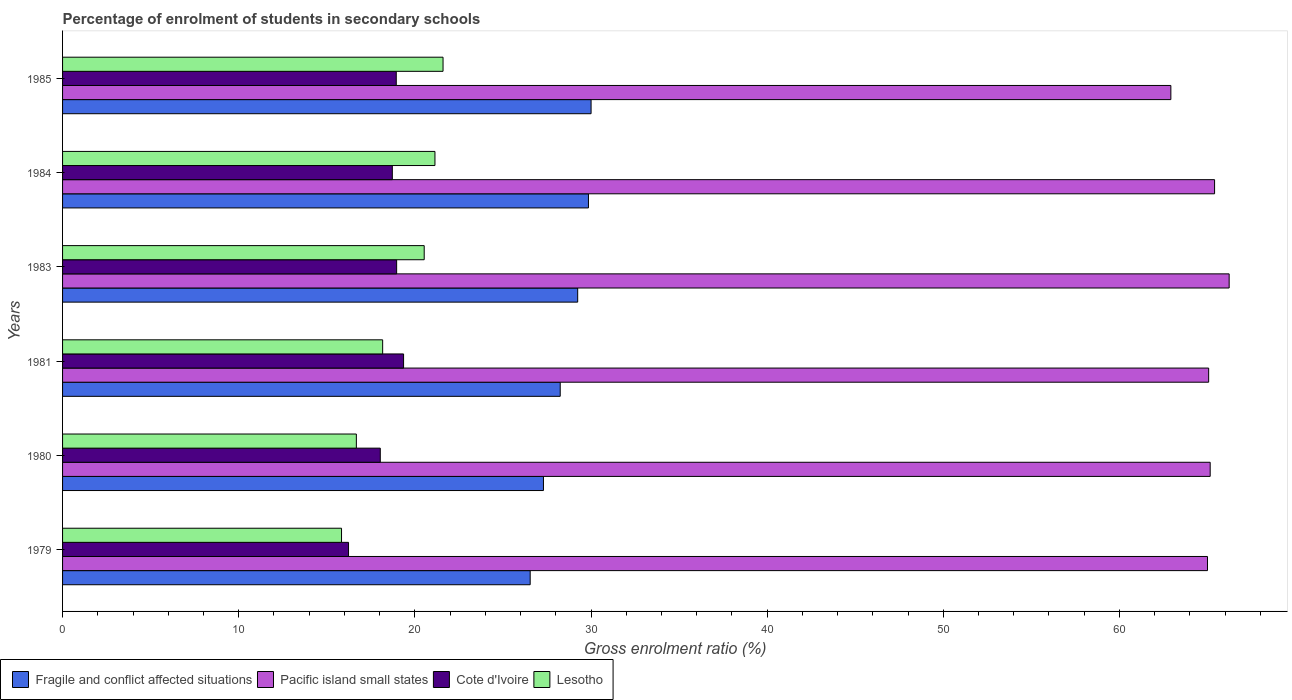Are the number of bars on each tick of the Y-axis equal?
Your answer should be very brief. Yes. How many bars are there on the 5th tick from the top?
Your answer should be very brief. 4. How many bars are there on the 2nd tick from the bottom?
Offer a very short reply. 4. In how many cases, is the number of bars for a given year not equal to the number of legend labels?
Your answer should be compact. 0. What is the percentage of students enrolled in secondary schools in Fragile and conflict affected situations in 1983?
Ensure brevity in your answer.  29.24. Across all years, what is the maximum percentage of students enrolled in secondary schools in Fragile and conflict affected situations?
Give a very brief answer. 30.01. Across all years, what is the minimum percentage of students enrolled in secondary schools in Fragile and conflict affected situations?
Provide a succinct answer. 26.55. In which year was the percentage of students enrolled in secondary schools in Lesotho maximum?
Keep it short and to the point. 1985. In which year was the percentage of students enrolled in secondary schools in Lesotho minimum?
Your answer should be very brief. 1979. What is the total percentage of students enrolled in secondary schools in Fragile and conflict affected situations in the graph?
Provide a short and direct response. 171.21. What is the difference between the percentage of students enrolled in secondary schools in Fragile and conflict affected situations in 1980 and that in 1981?
Your answer should be compact. -0.95. What is the difference between the percentage of students enrolled in secondary schools in Pacific island small states in 1983 and the percentage of students enrolled in secondary schools in Cote d'Ivoire in 1984?
Give a very brief answer. 47.51. What is the average percentage of students enrolled in secondary schools in Pacific island small states per year?
Your answer should be compact. 64.96. In the year 1984, what is the difference between the percentage of students enrolled in secondary schools in Lesotho and percentage of students enrolled in secondary schools in Cote d'Ivoire?
Provide a short and direct response. 2.42. In how many years, is the percentage of students enrolled in secondary schools in Cote d'Ivoire greater than 48 %?
Your response must be concise. 0. What is the ratio of the percentage of students enrolled in secondary schools in Pacific island small states in 1980 to that in 1981?
Keep it short and to the point. 1. Is the percentage of students enrolled in secondary schools in Lesotho in 1983 less than that in 1984?
Your answer should be compact. Yes. Is the difference between the percentage of students enrolled in secondary schools in Lesotho in 1979 and 1984 greater than the difference between the percentage of students enrolled in secondary schools in Cote d'Ivoire in 1979 and 1984?
Provide a short and direct response. No. What is the difference between the highest and the second highest percentage of students enrolled in secondary schools in Lesotho?
Ensure brevity in your answer.  0.46. What is the difference between the highest and the lowest percentage of students enrolled in secondary schools in Cote d'Ivoire?
Keep it short and to the point. 3.13. In how many years, is the percentage of students enrolled in secondary schools in Lesotho greater than the average percentage of students enrolled in secondary schools in Lesotho taken over all years?
Keep it short and to the point. 3. Is the sum of the percentage of students enrolled in secondary schools in Fragile and conflict affected situations in 1979 and 1983 greater than the maximum percentage of students enrolled in secondary schools in Lesotho across all years?
Ensure brevity in your answer.  Yes. Is it the case that in every year, the sum of the percentage of students enrolled in secondary schools in Fragile and conflict affected situations and percentage of students enrolled in secondary schools in Lesotho is greater than the sum of percentage of students enrolled in secondary schools in Pacific island small states and percentage of students enrolled in secondary schools in Cote d'Ivoire?
Provide a succinct answer. Yes. What does the 4th bar from the top in 1979 represents?
Ensure brevity in your answer.  Fragile and conflict affected situations. What does the 4th bar from the bottom in 1983 represents?
Give a very brief answer. Lesotho. How many bars are there?
Your response must be concise. 24. How many years are there in the graph?
Offer a terse response. 6. Are the values on the major ticks of X-axis written in scientific E-notation?
Give a very brief answer. No. Does the graph contain any zero values?
Your answer should be compact. No. Does the graph contain grids?
Offer a very short reply. No. How many legend labels are there?
Offer a very short reply. 4. How are the legend labels stacked?
Provide a succinct answer. Horizontal. What is the title of the graph?
Make the answer very short. Percentage of enrolment of students in secondary schools. What is the label or title of the X-axis?
Make the answer very short. Gross enrolment ratio (%). What is the Gross enrolment ratio (%) in Fragile and conflict affected situations in 1979?
Offer a terse response. 26.55. What is the Gross enrolment ratio (%) of Pacific island small states in 1979?
Your response must be concise. 65. What is the Gross enrolment ratio (%) in Cote d'Ivoire in 1979?
Give a very brief answer. 16.23. What is the Gross enrolment ratio (%) in Lesotho in 1979?
Provide a succinct answer. 15.84. What is the Gross enrolment ratio (%) of Fragile and conflict affected situations in 1980?
Your answer should be compact. 27.3. What is the Gross enrolment ratio (%) of Pacific island small states in 1980?
Offer a terse response. 65.15. What is the Gross enrolment ratio (%) in Cote d'Ivoire in 1980?
Offer a very short reply. 18.04. What is the Gross enrolment ratio (%) in Lesotho in 1980?
Offer a terse response. 16.68. What is the Gross enrolment ratio (%) of Fragile and conflict affected situations in 1981?
Offer a terse response. 28.25. What is the Gross enrolment ratio (%) of Pacific island small states in 1981?
Provide a succinct answer. 65.07. What is the Gross enrolment ratio (%) of Cote d'Ivoire in 1981?
Give a very brief answer. 19.36. What is the Gross enrolment ratio (%) of Lesotho in 1981?
Offer a terse response. 18.17. What is the Gross enrolment ratio (%) in Fragile and conflict affected situations in 1983?
Offer a terse response. 29.24. What is the Gross enrolment ratio (%) of Pacific island small states in 1983?
Your answer should be very brief. 66.23. What is the Gross enrolment ratio (%) of Cote d'Ivoire in 1983?
Your response must be concise. 18.97. What is the Gross enrolment ratio (%) of Lesotho in 1983?
Your answer should be compact. 20.53. What is the Gross enrolment ratio (%) in Fragile and conflict affected situations in 1984?
Your response must be concise. 29.86. What is the Gross enrolment ratio (%) in Pacific island small states in 1984?
Ensure brevity in your answer.  65.4. What is the Gross enrolment ratio (%) of Cote d'Ivoire in 1984?
Offer a terse response. 18.72. What is the Gross enrolment ratio (%) in Lesotho in 1984?
Your answer should be compact. 21.14. What is the Gross enrolment ratio (%) in Fragile and conflict affected situations in 1985?
Your answer should be compact. 30.01. What is the Gross enrolment ratio (%) in Pacific island small states in 1985?
Ensure brevity in your answer.  62.92. What is the Gross enrolment ratio (%) in Cote d'Ivoire in 1985?
Provide a succinct answer. 18.94. What is the Gross enrolment ratio (%) of Lesotho in 1985?
Offer a very short reply. 21.6. Across all years, what is the maximum Gross enrolment ratio (%) of Fragile and conflict affected situations?
Ensure brevity in your answer.  30.01. Across all years, what is the maximum Gross enrolment ratio (%) of Pacific island small states?
Ensure brevity in your answer.  66.23. Across all years, what is the maximum Gross enrolment ratio (%) in Cote d'Ivoire?
Offer a terse response. 19.36. Across all years, what is the maximum Gross enrolment ratio (%) in Lesotho?
Keep it short and to the point. 21.6. Across all years, what is the minimum Gross enrolment ratio (%) in Fragile and conflict affected situations?
Give a very brief answer. 26.55. Across all years, what is the minimum Gross enrolment ratio (%) in Pacific island small states?
Give a very brief answer. 62.92. Across all years, what is the minimum Gross enrolment ratio (%) in Cote d'Ivoire?
Ensure brevity in your answer.  16.23. Across all years, what is the minimum Gross enrolment ratio (%) in Lesotho?
Your answer should be compact. 15.84. What is the total Gross enrolment ratio (%) in Fragile and conflict affected situations in the graph?
Provide a short and direct response. 171.21. What is the total Gross enrolment ratio (%) of Pacific island small states in the graph?
Make the answer very short. 389.77. What is the total Gross enrolment ratio (%) of Cote d'Ivoire in the graph?
Offer a terse response. 110.26. What is the total Gross enrolment ratio (%) of Lesotho in the graph?
Your answer should be very brief. 113.96. What is the difference between the Gross enrolment ratio (%) in Fragile and conflict affected situations in 1979 and that in 1980?
Offer a very short reply. -0.75. What is the difference between the Gross enrolment ratio (%) in Pacific island small states in 1979 and that in 1980?
Offer a very short reply. -0.15. What is the difference between the Gross enrolment ratio (%) of Cote d'Ivoire in 1979 and that in 1980?
Provide a succinct answer. -1.8. What is the difference between the Gross enrolment ratio (%) of Lesotho in 1979 and that in 1980?
Provide a short and direct response. -0.84. What is the difference between the Gross enrolment ratio (%) in Fragile and conflict affected situations in 1979 and that in 1981?
Keep it short and to the point. -1.7. What is the difference between the Gross enrolment ratio (%) of Pacific island small states in 1979 and that in 1981?
Give a very brief answer. -0.07. What is the difference between the Gross enrolment ratio (%) in Cote d'Ivoire in 1979 and that in 1981?
Give a very brief answer. -3.13. What is the difference between the Gross enrolment ratio (%) in Lesotho in 1979 and that in 1981?
Provide a succinct answer. -2.33. What is the difference between the Gross enrolment ratio (%) in Fragile and conflict affected situations in 1979 and that in 1983?
Offer a terse response. -2.7. What is the difference between the Gross enrolment ratio (%) of Pacific island small states in 1979 and that in 1983?
Your answer should be compact. -1.23. What is the difference between the Gross enrolment ratio (%) in Cote d'Ivoire in 1979 and that in 1983?
Provide a succinct answer. -2.73. What is the difference between the Gross enrolment ratio (%) in Lesotho in 1979 and that in 1983?
Keep it short and to the point. -4.69. What is the difference between the Gross enrolment ratio (%) of Fragile and conflict affected situations in 1979 and that in 1984?
Offer a very short reply. -3.31. What is the difference between the Gross enrolment ratio (%) in Pacific island small states in 1979 and that in 1984?
Offer a terse response. -0.4. What is the difference between the Gross enrolment ratio (%) of Cote d'Ivoire in 1979 and that in 1984?
Give a very brief answer. -2.49. What is the difference between the Gross enrolment ratio (%) of Lesotho in 1979 and that in 1984?
Offer a terse response. -5.3. What is the difference between the Gross enrolment ratio (%) of Fragile and conflict affected situations in 1979 and that in 1985?
Your response must be concise. -3.46. What is the difference between the Gross enrolment ratio (%) of Pacific island small states in 1979 and that in 1985?
Make the answer very short. 2.08. What is the difference between the Gross enrolment ratio (%) in Cote d'Ivoire in 1979 and that in 1985?
Your answer should be very brief. -2.71. What is the difference between the Gross enrolment ratio (%) in Lesotho in 1979 and that in 1985?
Your answer should be compact. -5.76. What is the difference between the Gross enrolment ratio (%) of Fragile and conflict affected situations in 1980 and that in 1981?
Your answer should be very brief. -0.95. What is the difference between the Gross enrolment ratio (%) in Pacific island small states in 1980 and that in 1981?
Your answer should be compact. 0.09. What is the difference between the Gross enrolment ratio (%) in Cote d'Ivoire in 1980 and that in 1981?
Make the answer very short. -1.32. What is the difference between the Gross enrolment ratio (%) in Lesotho in 1980 and that in 1981?
Provide a short and direct response. -1.49. What is the difference between the Gross enrolment ratio (%) in Fragile and conflict affected situations in 1980 and that in 1983?
Offer a very short reply. -1.94. What is the difference between the Gross enrolment ratio (%) in Pacific island small states in 1980 and that in 1983?
Keep it short and to the point. -1.08. What is the difference between the Gross enrolment ratio (%) of Cote d'Ivoire in 1980 and that in 1983?
Provide a succinct answer. -0.93. What is the difference between the Gross enrolment ratio (%) in Lesotho in 1980 and that in 1983?
Your answer should be compact. -3.85. What is the difference between the Gross enrolment ratio (%) of Fragile and conflict affected situations in 1980 and that in 1984?
Provide a succinct answer. -2.56. What is the difference between the Gross enrolment ratio (%) of Pacific island small states in 1980 and that in 1984?
Offer a very short reply. -0.25. What is the difference between the Gross enrolment ratio (%) in Cote d'Ivoire in 1980 and that in 1984?
Make the answer very short. -0.68. What is the difference between the Gross enrolment ratio (%) of Lesotho in 1980 and that in 1984?
Your answer should be compact. -4.46. What is the difference between the Gross enrolment ratio (%) of Fragile and conflict affected situations in 1980 and that in 1985?
Your answer should be very brief. -2.7. What is the difference between the Gross enrolment ratio (%) in Pacific island small states in 1980 and that in 1985?
Your answer should be compact. 2.23. What is the difference between the Gross enrolment ratio (%) in Cote d'Ivoire in 1980 and that in 1985?
Make the answer very short. -0.91. What is the difference between the Gross enrolment ratio (%) of Lesotho in 1980 and that in 1985?
Your answer should be compact. -4.92. What is the difference between the Gross enrolment ratio (%) in Fragile and conflict affected situations in 1981 and that in 1983?
Your answer should be very brief. -0.99. What is the difference between the Gross enrolment ratio (%) of Pacific island small states in 1981 and that in 1983?
Your answer should be very brief. -1.16. What is the difference between the Gross enrolment ratio (%) of Cote d'Ivoire in 1981 and that in 1983?
Offer a terse response. 0.39. What is the difference between the Gross enrolment ratio (%) of Lesotho in 1981 and that in 1983?
Give a very brief answer. -2.36. What is the difference between the Gross enrolment ratio (%) in Fragile and conflict affected situations in 1981 and that in 1984?
Your answer should be compact. -1.6. What is the difference between the Gross enrolment ratio (%) in Pacific island small states in 1981 and that in 1984?
Your answer should be very brief. -0.34. What is the difference between the Gross enrolment ratio (%) of Cote d'Ivoire in 1981 and that in 1984?
Offer a terse response. 0.64. What is the difference between the Gross enrolment ratio (%) in Lesotho in 1981 and that in 1984?
Your response must be concise. -2.97. What is the difference between the Gross enrolment ratio (%) of Fragile and conflict affected situations in 1981 and that in 1985?
Offer a terse response. -1.75. What is the difference between the Gross enrolment ratio (%) in Pacific island small states in 1981 and that in 1985?
Offer a terse response. 2.15. What is the difference between the Gross enrolment ratio (%) of Cote d'Ivoire in 1981 and that in 1985?
Give a very brief answer. 0.41. What is the difference between the Gross enrolment ratio (%) in Lesotho in 1981 and that in 1985?
Keep it short and to the point. -3.43. What is the difference between the Gross enrolment ratio (%) in Fragile and conflict affected situations in 1983 and that in 1984?
Your answer should be compact. -0.61. What is the difference between the Gross enrolment ratio (%) of Pacific island small states in 1983 and that in 1984?
Make the answer very short. 0.83. What is the difference between the Gross enrolment ratio (%) of Cote d'Ivoire in 1983 and that in 1984?
Give a very brief answer. 0.25. What is the difference between the Gross enrolment ratio (%) of Lesotho in 1983 and that in 1984?
Offer a very short reply. -0.61. What is the difference between the Gross enrolment ratio (%) of Fragile and conflict affected situations in 1983 and that in 1985?
Your answer should be compact. -0.76. What is the difference between the Gross enrolment ratio (%) in Pacific island small states in 1983 and that in 1985?
Provide a short and direct response. 3.31. What is the difference between the Gross enrolment ratio (%) in Cote d'Ivoire in 1983 and that in 1985?
Provide a short and direct response. 0.02. What is the difference between the Gross enrolment ratio (%) of Lesotho in 1983 and that in 1985?
Give a very brief answer. -1.07. What is the difference between the Gross enrolment ratio (%) of Fragile and conflict affected situations in 1984 and that in 1985?
Provide a short and direct response. -0.15. What is the difference between the Gross enrolment ratio (%) in Pacific island small states in 1984 and that in 1985?
Make the answer very short. 2.48. What is the difference between the Gross enrolment ratio (%) of Cote d'Ivoire in 1984 and that in 1985?
Offer a terse response. -0.22. What is the difference between the Gross enrolment ratio (%) of Lesotho in 1984 and that in 1985?
Ensure brevity in your answer.  -0.46. What is the difference between the Gross enrolment ratio (%) in Fragile and conflict affected situations in 1979 and the Gross enrolment ratio (%) in Pacific island small states in 1980?
Provide a succinct answer. -38.61. What is the difference between the Gross enrolment ratio (%) of Fragile and conflict affected situations in 1979 and the Gross enrolment ratio (%) of Cote d'Ivoire in 1980?
Offer a very short reply. 8.51. What is the difference between the Gross enrolment ratio (%) in Fragile and conflict affected situations in 1979 and the Gross enrolment ratio (%) in Lesotho in 1980?
Provide a short and direct response. 9.87. What is the difference between the Gross enrolment ratio (%) of Pacific island small states in 1979 and the Gross enrolment ratio (%) of Cote d'Ivoire in 1980?
Your answer should be compact. 46.96. What is the difference between the Gross enrolment ratio (%) of Pacific island small states in 1979 and the Gross enrolment ratio (%) of Lesotho in 1980?
Provide a short and direct response. 48.32. What is the difference between the Gross enrolment ratio (%) of Cote d'Ivoire in 1979 and the Gross enrolment ratio (%) of Lesotho in 1980?
Your response must be concise. -0.45. What is the difference between the Gross enrolment ratio (%) in Fragile and conflict affected situations in 1979 and the Gross enrolment ratio (%) in Pacific island small states in 1981?
Offer a very short reply. -38.52. What is the difference between the Gross enrolment ratio (%) in Fragile and conflict affected situations in 1979 and the Gross enrolment ratio (%) in Cote d'Ivoire in 1981?
Keep it short and to the point. 7.19. What is the difference between the Gross enrolment ratio (%) of Fragile and conflict affected situations in 1979 and the Gross enrolment ratio (%) of Lesotho in 1981?
Provide a short and direct response. 8.38. What is the difference between the Gross enrolment ratio (%) in Pacific island small states in 1979 and the Gross enrolment ratio (%) in Cote d'Ivoire in 1981?
Offer a very short reply. 45.64. What is the difference between the Gross enrolment ratio (%) of Pacific island small states in 1979 and the Gross enrolment ratio (%) of Lesotho in 1981?
Ensure brevity in your answer.  46.83. What is the difference between the Gross enrolment ratio (%) in Cote d'Ivoire in 1979 and the Gross enrolment ratio (%) in Lesotho in 1981?
Make the answer very short. -1.94. What is the difference between the Gross enrolment ratio (%) of Fragile and conflict affected situations in 1979 and the Gross enrolment ratio (%) of Pacific island small states in 1983?
Offer a very short reply. -39.68. What is the difference between the Gross enrolment ratio (%) of Fragile and conflict affected situations in 1979 and the Gross enrolment ratio (%) of Cote d'Ivoire in 1983?
Keep it short and to the point. 7.58. What is the difference between the Gross enrolment ratio (%) in Fragile and conflict affected situations in 1979 and the Gross enrolment ratio (%) in Lesotho in 1983?
Your response must be concise. 6.02. What is the difference between the Gross enrolment ratio (%) of Pacific island small states in 1979 and the Gross enrolment ratio (%) of Cote d'Ivoire in 1983?
Your answer should be very brief. 46.03. What is the difference between the Gross enrolment ratio (%) of Pacific island small states in 1979 and the Gross enrolment ratio (%) of Lesotho in 1983?
Keep it short and to the point. 44.47. What is the difference between the Gross enrolment ratio (%) of Cote d'Ivoire in 1979 and the Gross enrolment ratio (%) of Lesotho in 1983?
Give a very brief answer. -4.3. What is the difference between the Gross enrolment ratio (%) of Fragile and conflict affected situations in 1979 and the Gross enrolment ratio (%) of Pacific island small states in 1984?
Ensure brevity in your answer.  -38.85. What is the difference between the Gross enrolment ratio (%) of Fragile and conflict affected situations in 1979 and the Gross enrolment ratio (%) of Cote d'Ivoire in 1984?
Your response must be concise. 7.83. What is the difference between the Gross enrolment ratio (%) in Fragile and conflict affected situations in 1979 and the Gross enrolment ratio (%) in Lesotho in 1984?
Keep it short and to the point. 5.41. What is the difference between the Gross enrolment ratio (%) in Pacific island small states in 1979 and the Gross enrolment ratio (%) in Cote d'Ivoire in 1984?
Make the answer very short. 46.28. What is the difference between the Gross enrolment ratio (%) of Pacific island small states in 1979 and the Gross enrolment ratio (%) of Lesotho in 1984?
Offer a terse response. 43.86. What is the difference between the Gross enrolment ratio (%) in Cote d'Ivoire in 1979 and the Gross enrolment ratio (%) in Lesotho in 1984?
Offer a very short reply. -4.91. What is the difference between the Gross enrolment ratio (%) of Fragile and conflict affected situations in 1979 and the Gross enrolment ratio (%) of Pacific island small states in 1985?
Keep it short and to the point. -36.37. What is the difference between the Gross enrolment ratio (%) of Fragile and conflict affected situations in 1979 and the Gross enrolment ratio (%) of Cote d'Ivoire in 1985?
Your answer should be compact. 7.6. What is the difference between the Gross enrolment ratio (%) in Fragile and conflict affected situations in 1979 and the Gross enrolment ratio (%) in Lesotho in 1985?
Provide a short and direct response. 4.95. What is the difference between the Gross enrolment ratio (%) of Pacific island small states in 1979 and the Gross enrolment ratio (%) of Cote d'Ivoire in 1985?
Make the answer very short. 46.05. What is the difference between the Gross enrolment ratio (%) of Pacific island small states in 1979 and the Gross enrolment ratio (%) of Lesotho in 1985?
Give a very brief answer. 43.4. What is the difference between the Gross enrolment ratio (%) in Cote d'Ivoire in 1979 and the Gross enrolment ratio (%) in Lesotho in 1985?
Keep it short and to the point. -5.37. What is the difference between the Gross enrolment ratio (%) in Fragile and conflict affected situations in 1980 and the Gross enrolment ratio (%) in Pacific island small states in 1981?
Your response must be concise. -37.76. What is the difference between the Gross enrolment ratio (%) of Fragile and conflict affected situations in 1980 and the Gross enrolment ratio (%) of Cote d'Ivoire in 1981?
Keep it short and to the point. 7.94. What is the difference between the Gross enrolment ratio (%) in Fragile and conflict affected situations in 1980 and the Gross enrolment ratio (%) in Lesotho in 1981?
Your response must be concise. 9.13. What is the difference between the Gross enrolment ratio (%) of Pacific island small states in 1980 and the Gross enrolment ratio (%) of Cote d'Ivoire in 1981?
Provide a short and direct response. 45.79. What is the difference between the Gross enrolment ratio (%) in Pacific island small states in 1980 and the Gross enrolment ratio (%) in Lesotho in 1981?
Offer a terse response. 46.98. What is the difference between the Gross enrolment ratio (%) in Cote d'Ivoire in 1980 and the Gross enrolment ratio (%) in Lesotho in 1981?
Offer a very short reply. -0.13. What is the difference between the Gross enrolment ratio (%) in Fragile and conflict affected situations in 1980 and the Gross enrolment ratio (%) in Pacific island small states in 1983?
Provide a succinct answer. -38.93. What is the difference between the Gross enrolment ratio (%) of Fragile and conflict affected situations in 1980 and the Gross enrolment ratio (%) of Cote d'Ivoire in 1983?
Offer a terse response. 8.33. What is the difference between the Gross enrolment ratio (%) in Fragile and conflict affected situations in 1980 and the Gross enrolment ratio (%) in Lesotho in 1983?
Ensure brevity in your answer.  6.77. What is the difference between the Gross enrolment ratio (%) of Pacific island small states in 1980 and the Gross enrolment ratio (%) of Cote d'Ivoire in 1983?
Provide a short and direct response. 46.19. What is the difference between the Gross enrolment ratio (%) in Pacific island small states in 1980 and the Gross enrolment ratio (%) in Lesotho in 1983?
Keep it short and to the point. 44.62. What is the difference between the Gross enrolment ratio (%) in Cote d'Ivoire in 1980 and the Gross enrolment ratio (%) in Lesotho in 1983?
Your answer should be very brief. -2.49. What is the difference between the Gross enrolment ratio (%) in Fragile and conflict affected situations in 1980 and the Gross enrolment ratio (%) in Pacific island small states in 1984?
Ensure brevity in your answer.  -38.1. What is the difference between the Gross enrolment ratio (%) in Fragile and conflict affected situations in 1980 and the Gross enrolment ratio (%) in Cote d'Ivoire in 1984?
Ensure brevity in your answer.  8.58. What is the difference between the Gross enrolment ratio (%) of Fragile and conflict affected situations in 1980 and the Gross enrolment ratio (%) of Lesotho in 1984?
Your answer should be very brief. 6.16. What is the difference between the Gross enrolment ratio (%) of Pacific island small states in 1980 and the Gross enrolment ratio (%) of Cote d'Ivoire in 1984?
Make the answer very short. 46.43. What is the difference between the Gross enrolment ratio (%) of Pacific island small states in 1980 and the Gross enrolment ratio (%) of Lesotho in 1984?
Give a very brief answer. 44.01. What is the difference between the Gross enrolment ratio (%) in Cote d'Ivoire in 1980 and the Gross enrolment ratio (%) in Lesotho in 1984?
Make the answer very short. -3.1. What is the difference between the Gross enrolment ratio (%) in Fragile and conflict affected situations in 1980 and the Gross enrolment ratio (%) in Pacific island small states in 1985?
Ensure brevity in your answer.  -35.62. What is the difference between the Gross enrolment ratio (%) in Fragile and conflict affected situations in 1980 and the Gross enrolment ratio (%) in Cote d'Ivoire in 1985?
Offer a very short reply. 8.36. What is the difference between the Gross enrolment ratio (%) in Fragile and conflict affected situations in 1980 and the Gross enrolment ratio (%) in Lesotho in 1985?
Your response must be concise. 5.7. What is the difference between the Gross enrolment ratio (%) in Pacific island small states in 1980 and the Gross enrolment ratio (%) in Cote d'Ivoire in 1985?
Provide a short and direct response. 46.21. What is the difference between the Gross enrolment ratio (%) of Pacific island small states in 1980 and the Gross enrolment ratio (%) of Lesotho in 1985?
Give a very brief answer. 43.55. What is the difference between the Gross enrolment ratio (%) of Cote d'Ivoire in 1980 and the Gross enrolment ratio (%) of Lesotho in 1985?
Offer a terse response. -3.56. What is the difference between the Gross enrolment ratio (%) in Fragile and conflict affected situations in 1981 and the Gross enrolment ratio (%) in Pacific island small states in 1983?
Your answer should be compact. -37.98. What is the difference between the Gross enrolment ratio (%) of Fragile and conflict affected situations in 1981 and the Gross enrolment ratio (%) of Cote d'Ivoire in 1983?
Ensure brevity in your answer.  9.29. What is the difference between the Gross enrolment ratio (%) of Fragile and conflict affected situations in 1981 and the Gross enrolment ratio (%) of Lesotho in 1983?
Offer a very short reply. 7.72. What is the difference between the Gross enrolment ratio (%) of Pacific island small states in 1981 and the Gross enrolment ratio (%) of Cote d'Ivoire in 1983?
Your answer should be compact. 46.1. What is the difference between the Gross enrolment ratio (%) of Pacific island small states in 1981 and the Gross enrolment ratio (%) of Lesotho in 1983?
Make the answer very short. 44.53. What is the difference between the Gross enrolment ratio (%) in Cote d'Ivoire in 1981 and the Gross enrolment ratio (%) in Lesotho in 1983?
Give a very brief answer. -1.17. What is the difference between the Gross enrolment ratio (%) in Fragile and conflict affected situations in 1981 and the Gross enrolment ratio (%) in Pacific island small states in 1984?
Provide a succinct answer. -37.15. What is the difference between the Gross enrolment ratio (%) in Fragile and conflict affected situations in 1981 and the Gross enrolment ratio (%) in Cote d'Ivoire in 1984?
Keep it short and to the point. 9.53. What is the difference between the Gross enrolment ratio (%) in Fragile and conflict affected situations in 1981 and the Gross enrolment ratio (%) in Lesotho in 1984?
Offer a very short reply. 7.11. What is the difference between the Gross enrolment ratio (%) of Pacific island small states in 1981 and the Gross enrolment ratio (%) of Cote d'Ivoire in 1984?
Your response must be concise. 46.34. What is the difference between the Gross enrolment ratio (%) of Pacific island small states in 1981 and the Gross enrolment ratio (%) of Lesotho in 1984?
Offer a very short reply. 43.92. What is the difference between the Gross enrolment ratio (%) of Cote d'Ivoire in 1981 and the Gross enrolment ratio (%) of Lesotho in 1984?
Give a very brief answer. -1.78. What is the difference between the Gross enrolment ratio (%) of Fragile and conflict affected situations in 1981 and the Gross enrolment ratio (%) of Pacific island small states in 1985?
Keep it short and to the point. -34.67. What is the difference between the Gross enrolment ratio (%) in Fragile and conflict affected situations in 1981 and the Gross enrolment ratio (%) in Cote d'Ivoire in 1985?
Your answer should be compact. 9.31. What is the difference between the Gross enrolment ratio (%) of Fragile and conflict affected situations in 1981 and the Gross enrolment ratio (%) of Lesotho in 1985?
Offer a terse response. 6.65. What is the difference between the Gross enrolment ratio (%) of Pacific island small states in 1981 and the Gross enrolment ratio (%) of Cote d'Ivoire in 1985?
Keep it short and to the point. 46.12. What is the difference between the Gross enrolment ratio (%) in Pacific island small states in 1981 and the Gross enrolment ratio (%) in Lesotho in 1985?
Give a very brief answer. 43.47. What is the difference between the Gross enrolment ratio (%) of Cote d'Ivoire in 1981 and the Gross enrolment ratio (%) of Lesotho in 1985?
Give a very brief answer. -2.24. What is the difference between the Gross enrolment ratio (%) of Fragile and conflict affected situations in 1983 and the Gross enrolment ratio (%) of Pacific island small states in 1984?
Provide a succinct answer. -36.16. What is the difference between the Gross enrolment ratio (%) of Fragile and conflict affected situations in 1983 and the Gross enrolment ratio (%) of Cote d'Ivoire in 1984?
Your answer should be very brief. 10.52. What is the difference between the Gross enrolment ratio (%) in Fragile and conflict affected situations in 1983 and the Gross enrolment ratio (%) in Lesotho in 1984?
Provide a short and direct response. 8.1. What is the difference between the Gross enrolment ratio (%) in Pacific island small states in 1983 and the Gross enrolment ratio (%) in Cote d'Ivoire in 1984?
Ensure brevity in your answer.  47.51. What is the difference between the Gross enrolment ratio (%) in Pacific island small states in 1983 and the Gross enrolment ratio (%) in Lesotho in 1984?
Keep it short and to the point. 45.09. What is the difference between the Gross enrolment ratio (%) of Cote d'Ivoire in 1983 and the Gross enrolment ratio (%) of Lesotho in 1984?
Make the answer very short. -2.17. What is the difference between the Gross enrolment ratio (%) in Fragile and conflict affected situations in 1983 and the Gross enrolment ratio (%) in Pacific island small states in 1985?
Provide a short and direct response. -33.68. What is the difference between the Gross enrolment ratio (%) in Fragile and conflict affected situations in 1983 and the Gross enrolment ratio (%) in Cote d'Ivoire in 1985?
Give a very brief answer. 10.3. What is the difference between the Gross enrolment ratio (%) of Fragile and conflict affected situations in 1983 and the Gross enrolment ratio (%) of Lesotho in 1985?
Offer a very short reply. 7.64. What is the difference between the Gross enrolment ratio (%) in Pacific island small states in 1983 and the Gross enrolment ratio (%) in Cote d'Ivoire in 1985?
Your answer should be very brief. 47.29. What is the difference between the Gross enrolment ratio (%) of Pacific island small states in 1983 and the Gross enrolment ratio (%) of Lesotho in 1985?
Your response must be concise. 44.63. What is the difference between the Gross enrolment ratio (%) of Cote d'Ivoire in 1983 and the Gross enrolment ratio (%) of Lesotho in 1985?
Provide a short and direct response. -2.63. What is the difference between the Gross enrolment ratio (%) in Fragile and conflict affected situations in 1984 and the Gross enrolment ratio (%) in Pacific island small states in 1985?
Your answer should be compact. -33.06. What is the difference between the Gross enrolment ratio (%) of Fragile and conflict affected situations in 1984 and the Gross enrolment ratio (%) of Cote d'Ivoire in 1985?
Keep it short and to the point. 10.91. What is the difference between the Gross enrolment ratio (%) in Fragile and conflict affected situations in 1984 and the Gross enrolment ratio (%) in Lesotho in 1985?
Offer a very short reply. 8.26. What is the difference between the Gross enrolment ratio (%) of Pacific island small states in 1984 and the Gross enrolment ratio (%) of Cote d'Ivoire in 1985?
Offer a terse response. 46.46. What is the difference between the Gross enrolment ratio (%) in Pacific island small states in 1984 and the Gross enrolment ratio (%) in Lesotho in 1985?
Provide a short and direct response. 43.8. What is the difference between the Gross enrolment ratio (%) in Cote d'Ivoire in 1984 and the Gross enrolment ratio (%) in Lesotho in 1985?
Provide a succinct answer. -2.88. What is the average Gross enrolment ratio (%) of Fragile and conflict affected situations per year?
Your answer should be compact. 28.53. What is the average Gross enrolment ratio (%) in Pacific island small states per year?
Offer a terse response. 64.96. What is the average Gross enrolment ratio (%) of Cote d'Ivoire per year?
Your answer should be very brief. 18.38. What is the average Gross enrolment ratio (%) in Lesotho per year?
Make the answer very short. 18.99. In the year 1979, what is the difference between the Gross enrolment ratio (%) of Fragile and conflict affected situations and Gross enrolment ratio (%) of Pacific island small states?
Give a very brief answer. -38.45. In the year 1979, what is the difference between the Gross enrolment ratio (%) of Fragile and conflict affected situations and Gross enrolment ratio (%) of Cote d'Ivoire?
Provide a succinct answer. 10.31. In the year 1979, what is the difference between the Gross enrolment ratio (%) of Fragile and conflict affected situations and Gross enrolment ratio (%) of Lesotho?
Provide a succinct answer. 10.71. In the year 1979, what is the difference between the Gross enrolment ratio (%) in Pacific island small states and Gross enrolment ratio (%) in Cote d'Ivoire?
Your answer should be compact. 48.77. In the year 1979, what is the difference between the Gross enrolment ratio (%) in Pacific island small states and Gross enrolment ratio (%) in Lesotho?
Make the answer very short. 49.16. In the year 1979, what is the difference between the Gross enrolment ratio (%) in Cote d'Ivoire and Gross enrolment ratio (%) in Lesotho?
Give a very brief answer. 0.4. In the year 1980, what is the difference between the Gross enrolment ratio (%) of Fragile and conflict affected situations and Gross enrolment ratio (%) of Pacific island small states?
Your response must be concise. -37.85. In the year 1980, what is the difference between the Gross enrolment ratio (%) in Fragile and conflict affected situations and Gross enrolment ratio (%) in Cote d'Ivoire?
Your response must be concise. 9.26. In the year 1980, what is the difference between the Gross enrolment ratio (%) of Fragile and conflict affected situations and Gross enrolment ratio (%) of Lesotho?
Keep it short and to the point. 10.62. In the year 1980, what is the difference between the Gross enrolment ratio (%) of Pacific island small states and Gross enrolment ratio (%) of Cote d'Ivoire?
Keep it short and to the point. 47.12. In the year 1980, what is the difference between the Gross enrolment ratio (%) of Pacific island small states and Gross enrolment ratio (%) of Lesotho?
Your response must be concise. 48.47. In the year 1980, what is the difference between the Gross enrolment ratio (%) of Cote d'Ivoire and Gross enrolment ratio (%) of Lesotho?
Offer a terse response. 1.36. In the year 1981, what is the difference between the Gross enrolment ratio (%) of Fragile and conflict affected situations and Gross enrolment ratio (%) of Pacific island small states?
Your answer should be very brief. -36.81. In the year 1981, what is the difference between the Gross enrolment ratio (%) in Fragile and conflict affected situations and Gross enrolment ratio (%) in Cote d'Ivoire?
Keep it short and to the point. 8.89. In the year 1981, what is the difference between the Gross enrolment ratio (%) of Fragile and conflict affected situations and Gross enrolment ratio (%) of Lesotho?
Your response must be concise. 10.08. In the year 1981, what is the difference between the Gross enrolment ratio (%) of Pacific island small states and Gross enrolment ratio (%) of Cote d'Ivoire?
Make the answer very short. 45.71. In the year 1981, what is the difference between the Gross enrolment ratio (%) in Pacific island small states and Gross enrolment ratio (%) in Lesotho?
Make the answer very short. 46.89. In the year 1981, what is the difference between the Gross enrolment ratio (%) in Cote d'Ivoire and Gross enrolment ratio (%) in Lesotho?
Keep it short and to the point. 1.19. In the year 1983, what is the difference between the Gross enrolment ratio (%) in Fragile and conflict affected situations and Gross enrolment ratio (%) in Pacific island small states?
Make the answer very short. -36.99. In the year 1983, what is the difference between the Gross enrolment ratio (%) in Fragile and conflict affected situations and Gross enrolment ratio (%) in Cote d'Ivoire?
Provide a succinct answer. 10.28. In the year 1983, what is the difference between the Gross enrolment ratio (%) of Fragile and conflict affected situations and Gross enrolment ratio (%) of Lesotho?
Provide a short and direct response. 8.71. In the year 1983, what is the difference between the Gross enrolment ratio (%) of Pacific island small states and Gross enrolment ratio (%) of Cote d'Ivoire?
Keep it short and to the point. 47.26. In the year 1983, what is the difference between the Gross enrolment ratio (%) in Pacific island small states and Gross enrolment ratio (%) in Lesotho?
Offer a very short reply. 45.7. In the year 1983, what is the difference between the Gross enrolment ratio (%) in Cote d'Ivoire and Gross enrolment ratio (%) in Lesotho?
Make the answer very short. -1.56. In the year 1984, what is the difference between the Gross enrolment ratio (%) in Fragile and conflict affected situations and Gross enrolment ratio (%) in Pacific island small states?
Make the answer very short. -35.55. In the year 1984, what is the difference between the Gross enrolment ratio (%) of Fragile and conflict affected situations and Gross enrolment ratio (%) of Cote d'Ivoire?
Ensure brevity in your answer.  11.13. In the year 1984, what is the difference between the Gross enrolment ratio (%) of Fragile and conflict affected situations and Gross enrolment ratio (%) of Lesotho?
Give a very brief answer. 8.71. In the year 1984, what is the difference between the Gross enrolment ratio (%) in Pacific island small states and Gross enrolment ratio (%) in Cote d'Ivoire?
Ensure brevity in your answer.  46.68. In the year 1984, what is the difference between the Gross enrolment ratio (%) of Pacific island small states and Gross enrolment ratio (%) of Lesotho?
Ensure brevity in your answer.  44.26. In the year 1984, what is the difference between the Gross enrolment ratio (%) in Cote d'Ivoire and Gross enrolment ratio (%) in Lesotho?
Give a very brief answer. -2.42. In the year 1985, what is the difference between the Gross enrolment ratio (%) of Fragile and conflict affected situations and Gross enrolment ratio (%) of Pacific island small states?
Provide a succinct answer. -32.91. In the year 1985, what is the difference between the Gross enrolment ratio (%) of Fragile and conflict affected situations and Gross enrolment ratio (%) of Cote d'Ivoire?
Keep it short and to the point. 11.06. In the year 1985, what is the difference between the Gross enrolment ratio (%) of Fragile and conflict affected situations and Gross enrolment ratio (%) of Lesotho?
Keep it short and to the point. 8.4. In the year 1985, what is the difference between the Gross enrolment ratio (%) of Pacific island small states and Gross enrolment ratio (%) of Cote d'Ivoire?
Provide a short and direct response. 43.97. In the year 1985, what is the difference between the Gross enrolment ratio (%) in Pacific island small states and Gross enrolment ratio (%) in Lesotho?
Provide a succinct answer. 41.32. In the year 1985, what is the difference between the Gross enrolment ratio (%) in Cote d'Ivoire and Gross enrolment ratio (%) in Lesotho?
Provide a short and direct response. -2.66. What is the ratio of the Gross enrolment ratio (%) of Fragile and conflict affected situations in 1979 to that in 1980?
Your answer should be compact. 0.97. What is the ratio of the Gross enrolment ratio (%) in Cote d'Ivoire in 1979 to that in 1980?
Keep it short and to the point. 0.9. What is the ratio of the Gross enrolment ratio (%) of Lesotho in 1979 to that in 1980?
Your answer should be very brief. 0.95. What is the ratio of the Gross enrolment ratio (%) of Fragile and conflict affected situations in 1979 to that in 1981?
Your response must be concise. 0.94. What is the ratio of the Gross enrolment ratio (%) in Pacific island small states in 1979 to that in 1981?
Offer a very short reply. 1. What is the ratio of the Gross enrolment ratio (%) of Cote d'Ivoire in 1979 to that in 1981?
Your answer should be compact. 0.84. What is the ratio of the Gross enrolment ratio (%) of Lesotho in 1979 to that in 1981?
Keep it short and to the point. 0.87. What is the ratio of the Gross enrolment ratio (%) of Fragile and conflict affected situations in 1979 to that in 1983?
Your response must be concise. 0.91. What is the ratio of the Gross enrolment ratio (%) in Pacific island small states in 1979 to that in 1983?
Give a very brief answer. 0.98. What is the ratio of the Gross enrolment ratio (%) in Cote d'Ivoire in 1979 to that in 1983?
Offer a very short reply. 0.86. What is the ratio of the Gross enrolment ratio (%) of Lesotho in 1979 to that in 1983?
Give a very brief answer. 0.77. What is the ratio of the Gross enrolment ratio (%) in Fragile and conflict affected situations in 1979 to that in 1984?
Provide a short and direct response. 0.89. What is the ratio of the Gross enrolment ratio (%) in Pacific island small states in 1979 to that in 1984?
Your answer should be compact. 0.99. What is the ratio of the Gross enrolment ratio (%) in Cote d'Ivoire in 1979 to that in 1984?
Make the answer very short. 0.87. What is the ratio of the Gross enrolment ratio (%) of Lesotho in 1979 to that in 1984?
Offer a terse response. 0.75. What is the ratio of the Gross enrolment ratio (%) in Fragile and conflict affected situations in 1979 to that in 1985?
Provide a short and direct response. 0.88. What is the ratio of the Gross enrolment ratio (%) in Pacific island small states in 1979 to that in 1985?
Your answer should be very brief. 1.03. What is the ratio of the Gross enrolment ratio (%) of Cote d'Ivoire in 1979 to that in 1985?
Make the answer very short. 0.86. What is the ratio of the Gross enrolment ratio (%) of Lesotho in 1979 to that in 1985?
Give a very brief answer. 0.73. What is the ratio of the Gross enrolment ratio (%) in Fragile and conflict affected situations in 1980 to that in 1981?
Offer a terse response. 0.97. What is the ratio of the Gross enrolment ratio (%) in Pacific island small states in 1980 to that in 1981?
Provide a short and direct response. 1. What is the ratio of the Gross enrolment ratio (%) of Cote d'Ivoire in 1980 to that in 1981?
Make the answer very short. 0.93. What is the ratio of the Gross enrolment ratio (%) of Lesotho in 1980 to that in 1981?
Your answer should be very brief. 0.92. What is the ratio of the Gross enrolment ratio (%) of Fragile and conflict affected situations in 1980 to that in 1983?
Ensure brevity in your answer.  0.93. What is the ratio of the Gross enrolment ratio (%) of Pacific island small states in 1980 to that in 1983?
Your answer should be compact. 0.98. What is the ratio of the Gross enrolment ratio (%) in Cote d'Ivoire in 1980 to that in 1983?
Your response must be concise. 0.95. What is the ratio of the Gross enrolment ratio (%) of Lesotho in 1980 to that in 1983?
Keep it short and to the point. 0.81. What is the ratio of the Gross enrolment ratio (%) in Fragile and conflict affected situations in 1980 to that in 1984?
Keep it short and to the point. 0.91. What is the ratio of the Gross enrolment ratio (%) in Cote d'Ivoire in 1980 to that in 1984?
Make the answer very short. 0.96. What is the ratio of the Gross enrolment ratio (%) of Lesotho in 1980 to that in 1984?
Your answer should be compact. 0.79. What is the ratio of the Gross enrolment ratio (%) of Fragile and conflict affected situations in 1980 to that in 1985?
Your answer should be compact. 0.91. What is the ratio of the Gross enrolment ratio (%) of Pacific island small states in 1980 to that in 1985?
Make the answer very short. 1.04. What is the ratio of the Gross enrolment ratio (%) in Cote d'Ivoire in 1980 to that in 1985?
Offer a very short reply. 0.95. What is the ratio of the Gross enrolment ratio (%) of Lesotho in 1980 to that in 1985?
Offer a terse response. 0.77. What is the ratio of the Gross enrolment ratio (%) of Fragile and conflict affected situations in 1981 to that in 1983?
Keep it short and to the point. 0.97. What is the ratio of the Gross enrolment ratio (%) of Pacific island small states in 1981 to that in 1983?
Offer a very short reply. 0.98. What is the ratio of the Gross enrolment ratio (%) in Cote d'Ivoire in 1981 to that in 1983?
Your answer should be compact. 1.02. What is the ratio of the Gross enrolment ratio (%) in Lesotho in 1981 to that in 1983?
Make the answer very short. 0.89. What is the ratio of the Gross enrolment ratio (%) in Fragile and conflict affected situations in 1981 to that in 1984?
Your response must be concise. 0.95. What is the ratio of the Gross enrolment ratio (%) in Pacific island small states in 1981 to that in 1984?
Make the answer very short. 0.99. What is the ratio of the Gross enrolment ratio (%) of Cote d'Ivoire in 1981 to that in 1984?
Your answer should be very brief. 1.03. What is the ratio of the Gross enrolment ratio (%) of Lesotho in 1981 to that in 1984?
Your answer should be very brief. 0.86. What is the ratio of the Gross enrolment ratio (%) of Fragile and conflict affected situations in 1981 to that in 1985?
Offer a very short reply. 0.94. What is the ratio of the Gross enrolment ratio (%) of Pacific island small states in 1981 to that in 1985?
Your answer should be very brief. 1.03. What is the ratio of the Gross enrolment ratio (%) of Cote d'Ivoire in 1981 to that in 1985?
Ensure brevity in your answer.  1.02. What is the ratio of the Gross enrolment ratio (%) of Lesotho in 1981 to that in 1985?
Your answer should be very brief. 0.84. What is the ratio of the Gross enrolment ratio (%) of Fragile and conflict affected situations in 1983 to that in 1984?
Your answer should be very brief. 0.98. What is the ratio of the Gross enrolment ratio (%) in Pacific island small states in 1983 to that in 1984?
Provide a succinct answer. 1.01. What is the ratio of the Gross enrolment ratio (%) in Cote d'Ivoire in 1983 to that in 1984?
Provide a succinct answer. 1.01. What is the ratio of the Gross enrolment ratio (%) of Lesotho in 1983 to that in 1984?
Provide a succinct answer. 0.97. What is the ratio of the Gross enrolment ratio (%) of Fragile and conflict affected situations in 1983 to that in 1985?
Make the answer very short. 0.97. What is the ratio of the Gross enrolment ratio (%) of Pacific island small states in 1983 to that in 1985?
Provide a succinct answer. 1.05. What is the ratio of the Gross enrolment ratio (%) in Cote d'Ivoire in 1983 to that in 1985?
Make the answer very short. 1. What is the ratio of the Gross enrolment ratio (%) in Lesotho in 1983 to that in 1985?
Your answer should be compact. 0.95. What is the ratio of the Gross enrolment ratio (%) in Pacific island small states in 1984 to that in 1985?
Offer a terse response. 1.04. What is the ratio of the Gross enrolment ratio (%) in Lesotho in 1984 to that in 1985?
Offer a terse response. 0.98. What is the difference between the highest and the second highest Gross enrolment ratio (%) of Fragile and conflict affected situations?
Provide a short and direct response. 0.15. What is the difference between the highest and the second highest Gross enrolment ratio (%) in Pacific island small states?
Your answer should be compact. 0.83. What is the difference between the highest and the second highest Gross enrolment ratio (%) of Cote d'Ivoire?
Your response must be concise. 0.39. What is the difference between the highest and the second highest Gross enrolment ratio (%) of Lesotho?
Offer a very short reply. 0.46. What is the difference between the highest and the lowest Gross enrolment ratio (%) in Fragile and conflict affected situations?
Offer a terse response. 3.46. What is the difference between the highest and the lowest Gross enrolment ratio (%) of Pacific island small states?
Your answer should be very brief. 3.31. What is the difference between the highest and the lowest Gross enrolment ratio (%) in Cote d'Ivoire?
Your response must be concise. 3.13. What is the difference between the highest and the lowest Gross enrolment ratio (%) in Lesotho?
Ensure brevity in your answer.  5.76. 